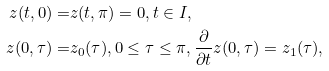<formula> <loc_0><loc_0><loc_500><loc_500>z ( t , 0 ) = & z ( t , \pi ) = 0 , t \in I , \\ z ( 0 , \tau ) = & z _ { 0 } ( \tau ) , 0 \leq \tau \leq \pi , \frac { \partial } { \partial t } z ( 0 , \tau ) = z _ { 1 } ( \tau ) ,</formula> 